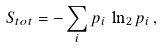<formula> <loc_0><loc_0><loc_500><loc_500>S _ { t o t } = - \sum _ { i } p _ { i } \, \ln _ { 2 } p _ { i } \, ,</formula> 